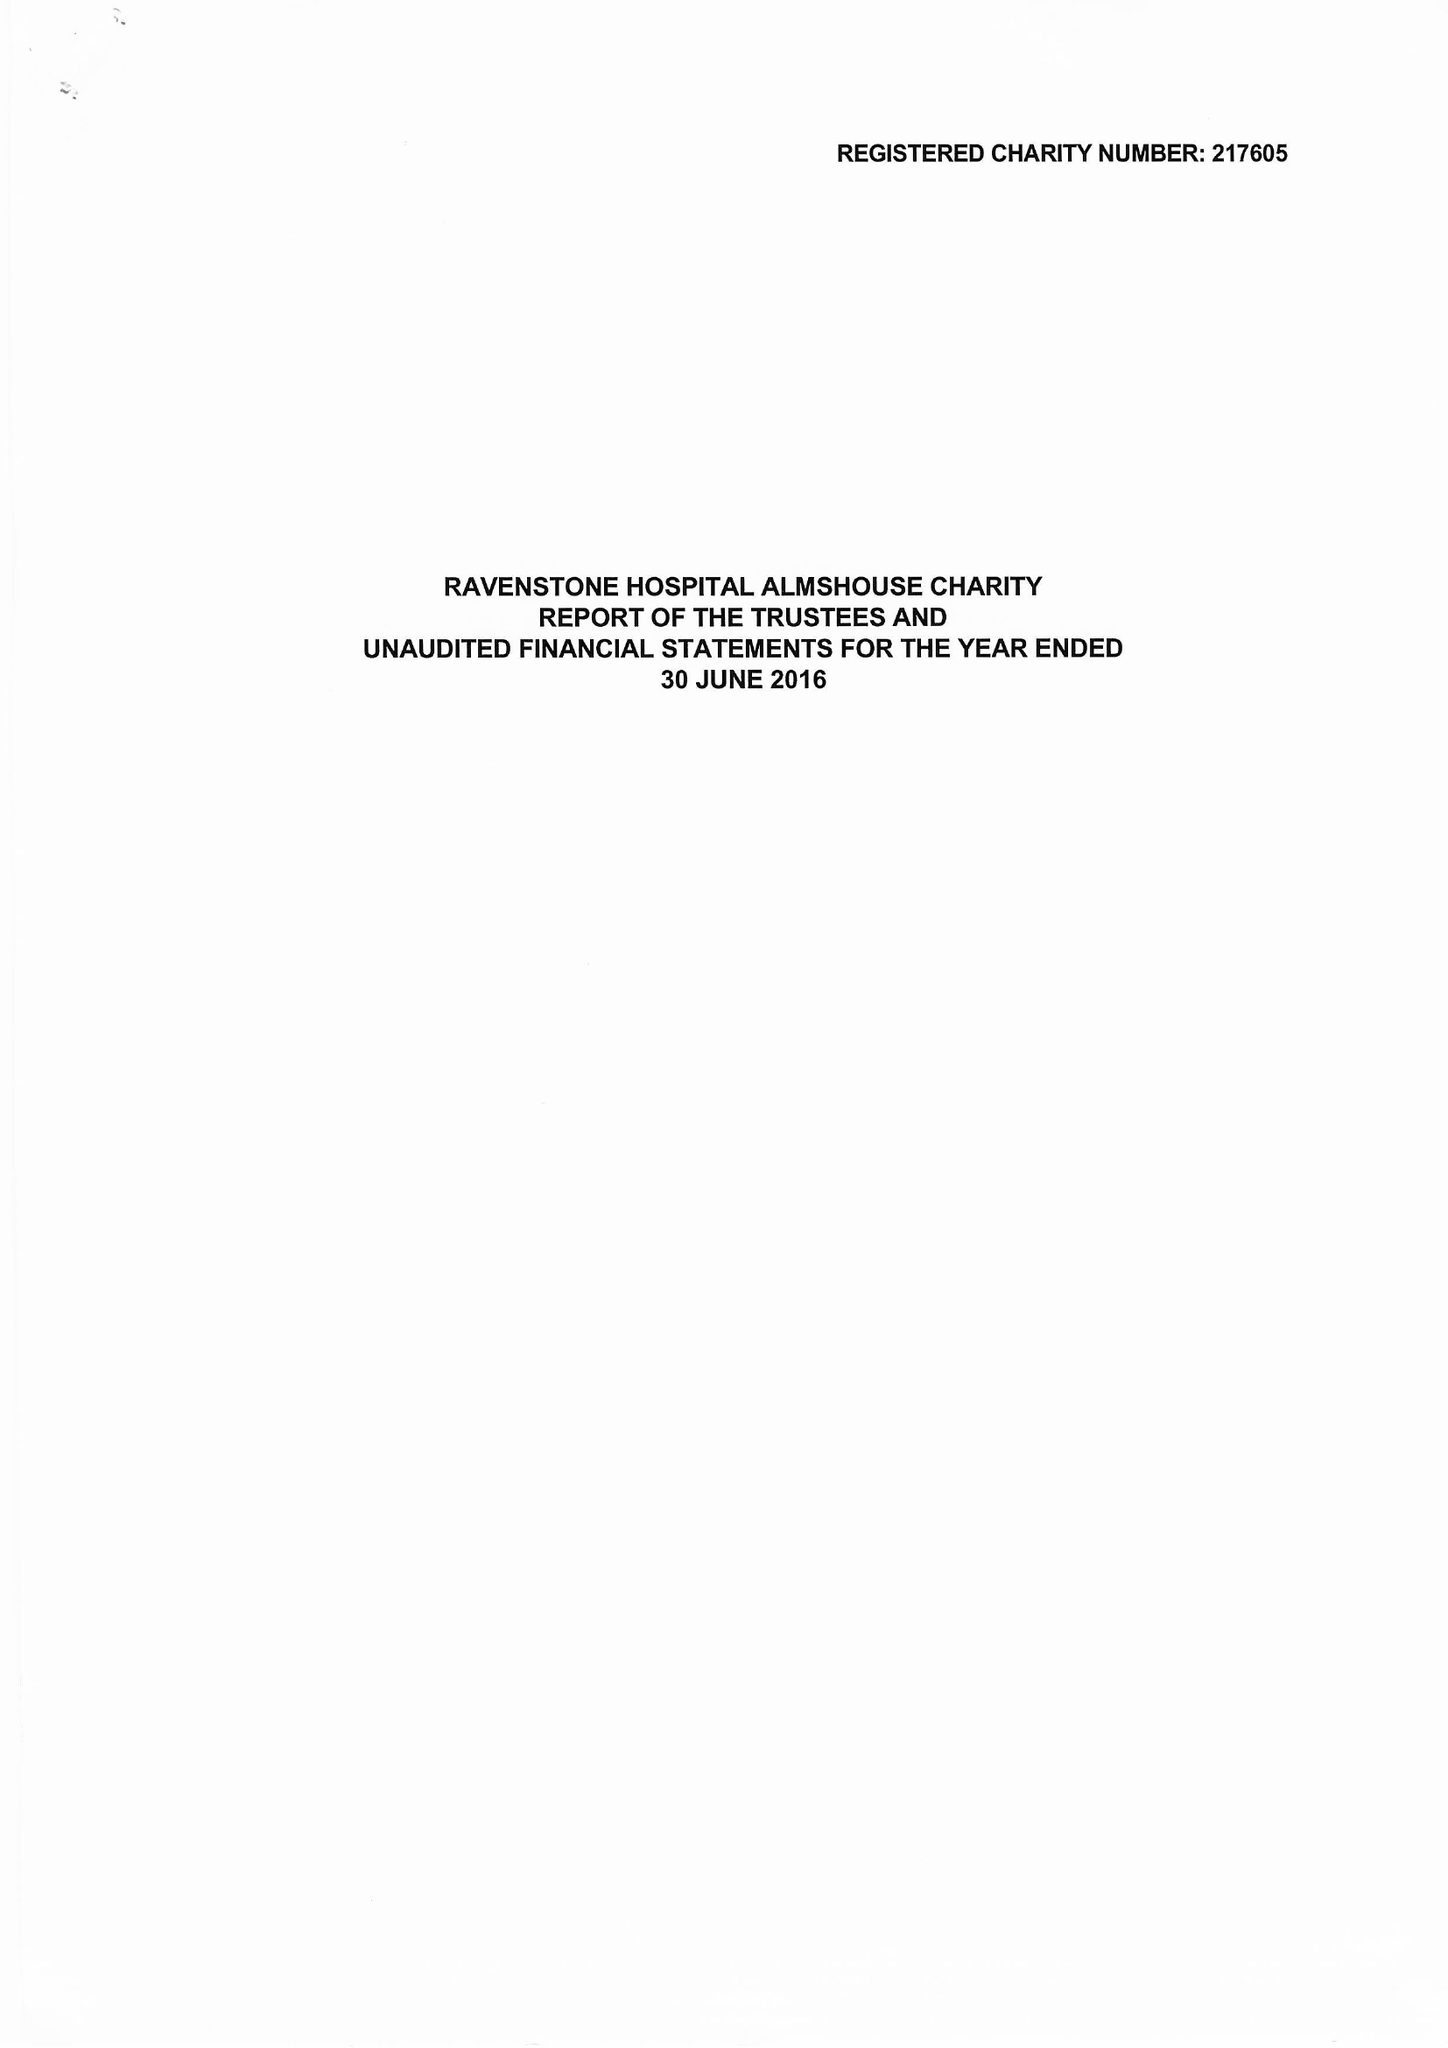What is the value for the spending_annually_in_british_pounds?
Answer the question using a single word or phrase. 296425.00 